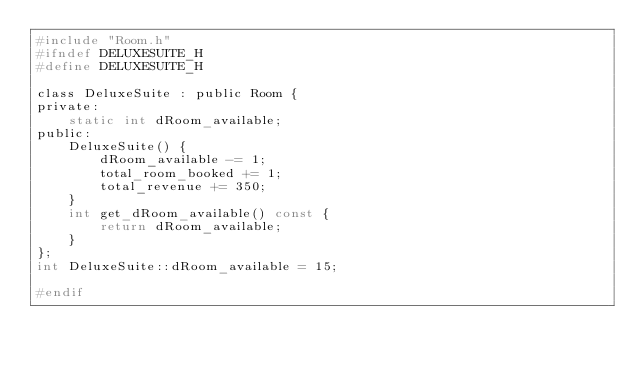<code> <loc_0><loc_0><loc_500><loc_500><_C_>#include "Room.h"
#ifndef DELUXESUITE_H
#define DELUXESUITE_H

class DeluxeSuite : public Room {
private:
    static int dRoom_available;
public:
    DeluxeSuite() {
        dRoom_available -= 1;
        total_room_booked += 1;
        total_revenue += 350;
    }
    int get_dRoom_available() const {
        return dRoom_available;
    }
};
int DeluxeSuite::dRoom_available = 15;

#endif</code> 